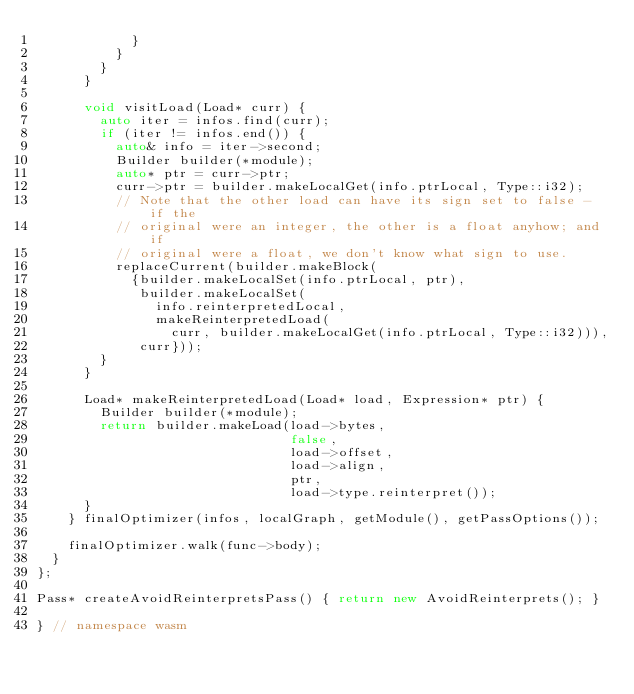<code> <loc_0><loc_0><loc_500><loc_500><_C++_>            }
          }
        }
      }

      void visitLoad(Load* curr) {
        auto iter = infos.find(curr);
        if (iter != infos.end()) {
          auto& info = iter->second;
          Builder builder(*module);
          auto* ptr = curr->ptr;
          curr->ptr = builder.makeLocalGet(info.ptrLocal, Type::i32);
          // Note that the other load can have its sign set to false - if the
          // original were an integer, the other is a float anyhow; and if
          // original were a float, we don't know what sign to use.
          replaceCurrent(builder.makeBlock(
            {builder.makeLocalSet(info.ptrLocal, ptr),
             builder.makeLocalSet(
               info.reinterpretedLocal,
               makeReinterpretedLoad(
                 curr, builder.makeLocalGet(info.ptrLocal, Type::i32))),
             curr}));
        }
      }

      Load* makeReinterpretedLoad(Load* load, Expression* ptr) {
        Builder builder(*module);
        return builder.makeLoad(load->bytes,
                                false,
                                load->offset,
                                load->align,
                                ptr,
                                load->type.reinterpret());
      }
    } finalOptimizer(infos, localGraph, getModule(), getPassOptions());

    finalOptimizer.walk(func->body);
  }
};

Pass* createAvoidReinterpretsPass() { return new AvoidReinterprets(); }

} // namespace wasm
</code> 